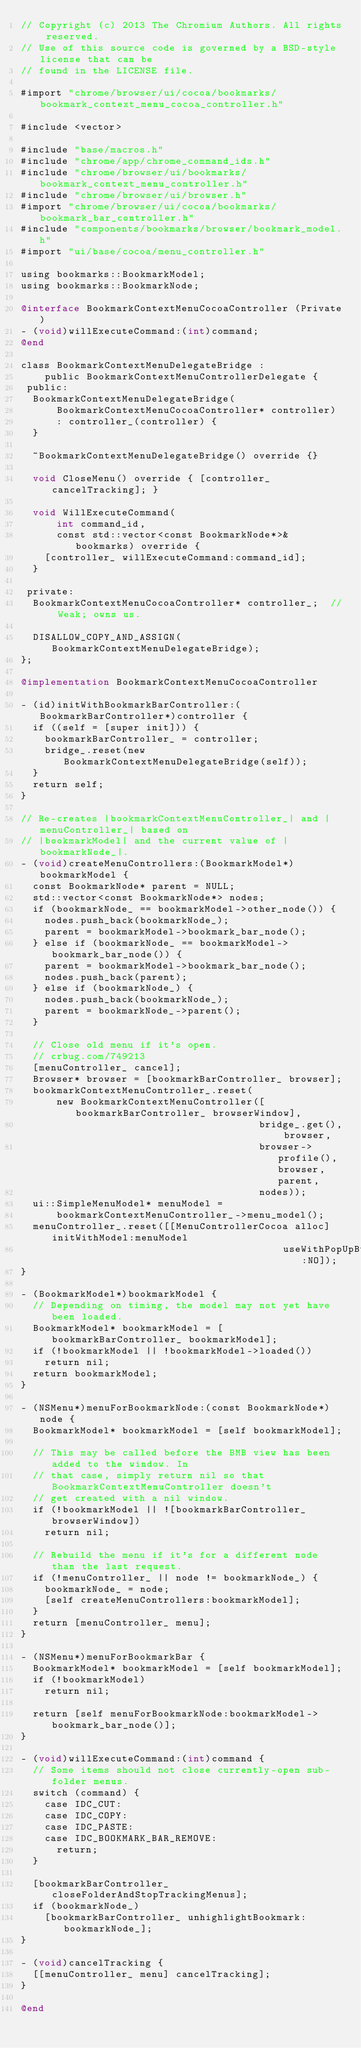<code> <loc_0><loc_0><loc_500><loc_500><_ObjectiveC_>// Copyright (c) 2013 The Chromium Authors. All rights reserved.
// Use of this source code is governed by a BSD-style license that can be
// found in the LICENSE file.

#import "chrome/browser/ui/cocoa/bookmarks/bookmark_context_menu_cocoa_controller.h"

#include <vector>

#include "base/macros.h"
#include "chrome/app/chrome_command_ids.h"
#include "chrome/browser/ui/bookmarks/bookmark_context_menu_controller.h"
#include "chrome/browser/ui/browser.h"
#import "chrome/browser/ui/cocoa/bookmarks/bookmark_bar_controller.h"
#include "components/bookmarks/browser/bookmark_model.h"
#import "ui/base/cocoa/menu_controller.h"

using bookmarks::BookmarkModel;
using bookmarks::BookmarkNode;

@interface BookmarkContextMenuCocoaController (Private)
- (void)willExecuteCommand:(int)command;
@end

class BookmarkContextMenuDelegateBridge :
    public BookmarkContextMenuControllerDelegate {
 public:
  BookmarkContextMenuDelegateBridge(
      BookmarkContextMenuCocoaController* controller)
      : controller_(controller) {
  }

  ~BookmarkContextMenuDelegateBridge() override {}

  void CloseMenu() override { [controller_ cancelTracking]; }

  void WillExecuteCommand(
      int command_id,
      const std::vector<const BookmarkNode*>& bookmarks) override {
    [controller_ willExecuteCommand:command_id];
  }

 private:
  BookmarkContextMenuCocoaController* controller_;  // Weak; owns us.

  DISALLOW_COPY_AND_ASSIGN(BookmarkContextMenuDelegateBridge);
};

@implementation BookmarkContextMenuCocoaController

- (id)initWithBookmarkBarController:(BookmarkBarController*)controller {
  if ((self = [super init])) {
    bookmarkBarController_ = controller;
    bridge_.reset(new BookmarkContextMenuDelegateBridge(self));
  }
  return self;
}

// Re-creates |bookmarkContextMenuController_| and |menuController_| based on
// |bookmarkModel| and the current value of |bookmarkNode_|.
- (void)createMenuControllers:(BookmarkModel*)bookmarkModel {
  const BookmarkNode* parent = NULL;
  std::vector<const BookmarkNode*> nodes;
  if (bookmarkNode_ == bookmarkModel->other_node()) {
    nodes.push_back(bookmarkNode_);
    parent = bookmarkModel->bookmark_bar_node();
  } else if (bookmarkNode_ == bookmarkModel->bookmark_bar_node()) {
    parent = bookmarkModel->bookmark_bar_node();
    nodes.push_back(parent);
  } else if (bookmarkNode_) {
    nodes.push_back(bookmarkNode_);
    parent = bookmarkNode_->parent();
  }

  // Close old menu if it's open.
  // crbug.com/749213
  [menuController_ cancel];
  Browser* browser = [bookmarkBarController_ browser];
  bookmarkContextMenuController_.reset(
      new BookmarkContextMenuController([bookmarkBarController_ browserWindow],
                                        bridge_.get(), browser,
                                        browser->profile(), browser, parent,
                                        nodes));
  ui::SimpleMenuModel* menuModel =
      bookmarkContextMenuController_->menu_model();
  menuController_.reset([[MenuControllerCocoa alloc] initWithModel:menuModel
                                            useWithPopUpButtonCell:NO]);
}

- (BookmarkModel*)bookmarkModel {
  // Depending on timing, the model may not yet have been loaded.
  BookmarkModel* bookmarkModel = [bookmarkBarController_ bookmarkModel];
  if (!bookmarkModel || !bookmarkModel->loaded())
    return nil;
  return bookmarkModel;
}

- (NSMenu*)menuForBookmarkNode:(const BookmarkNode*)node {
  BookmarkModel* bookmarkModel = [self bookmarkModel];

  // This may be called before the BMB view has been added to the window. In
  // that case, simply return nil so that BookmarkContextMenuController doesn't
  // get created with a nil window.
  if (!bookmarkModel || ![bookmarkBarController_ browserWindow])
    return nil;

  // Rebuild the menu if it's for a different node than the last request.
  if (!menuController_ || node != bookmarkNode_) {
    bookmarkNode_ = node;
    [self createMenuControllers:bookmarkModel];
  }
  return [menuController_ menu];
}

- (NSMenu*)menuForBookmarkBar {
  BookmarkModel* bookmarkModel = [self bookmarkModel];
  if (!bookmarkModel)
    return nil;

  return [self menuForBookmarkNode:bookmarkModel->bookmark_bar_node()];
}

- (void)willExecuteCommand:(int)command {
  // Some items should not close currently-open sub-folder menus.
  switch (command) {
    case IDC_CUT:
    case IDC_COPY:
    case IDC_PASTE:
    case IDC_BOOKMARK_BAR_REMOVE:
      return;
  }

  [bookmarkBarController_ closeFolderAndStopTrackingMenus];
  if (bookmarkNode_)
    [bookmarkBarController_ unhighlightBookmark:bookmarkNode_];
}

- (void)cancelTracking {
  [[menuController_ menu] cancelTracking];
}

@end
</code> 